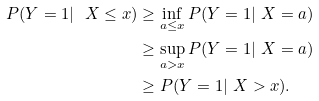Convert formula to latex. <formula><loc_0><loc_0><loc_500><loc_500>P ( Y = 1 | \ X \leq x ) & \geq \inf _ { a \leq x } P ( Y = 1 | \ X = a ) \\ & \geq \sup _ { a > x } P ( Y = 1 | \ X = a ) \\ & \geq P ( Y = 1 | \ X > x ) .</formula> 